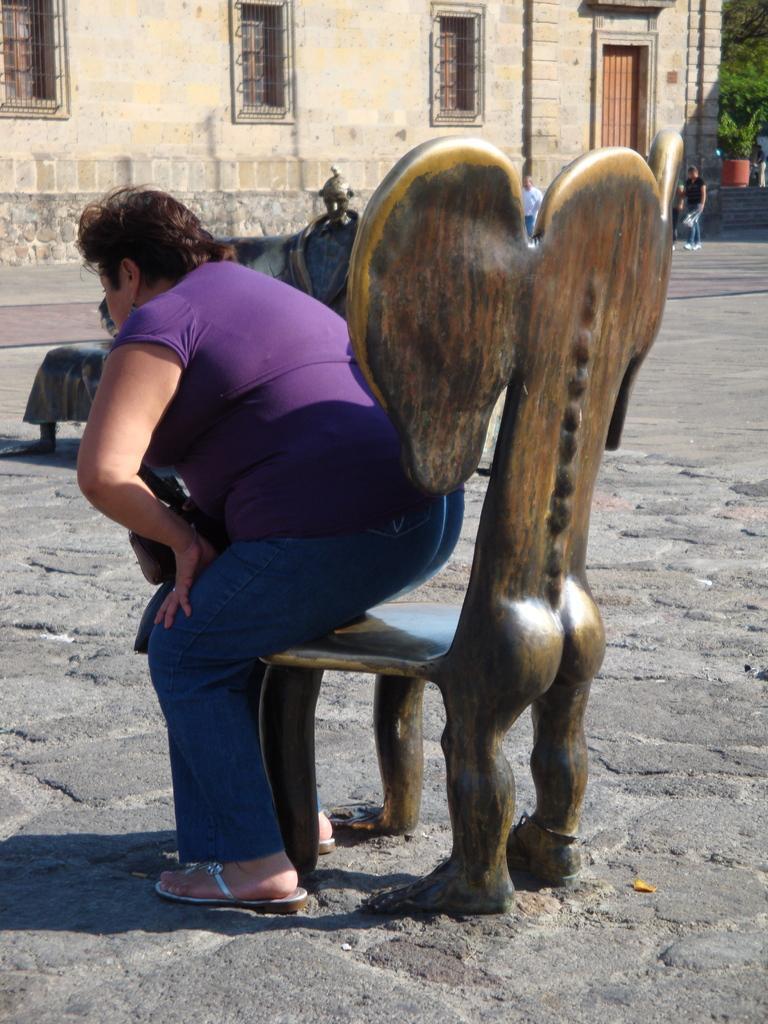Could you give a brief overview of what you see in this image? On the background we can see a house with door and windows. Here we can see trees. We can see persons walking near to the house. Here we can see one women , she is about to sit on a chair. 